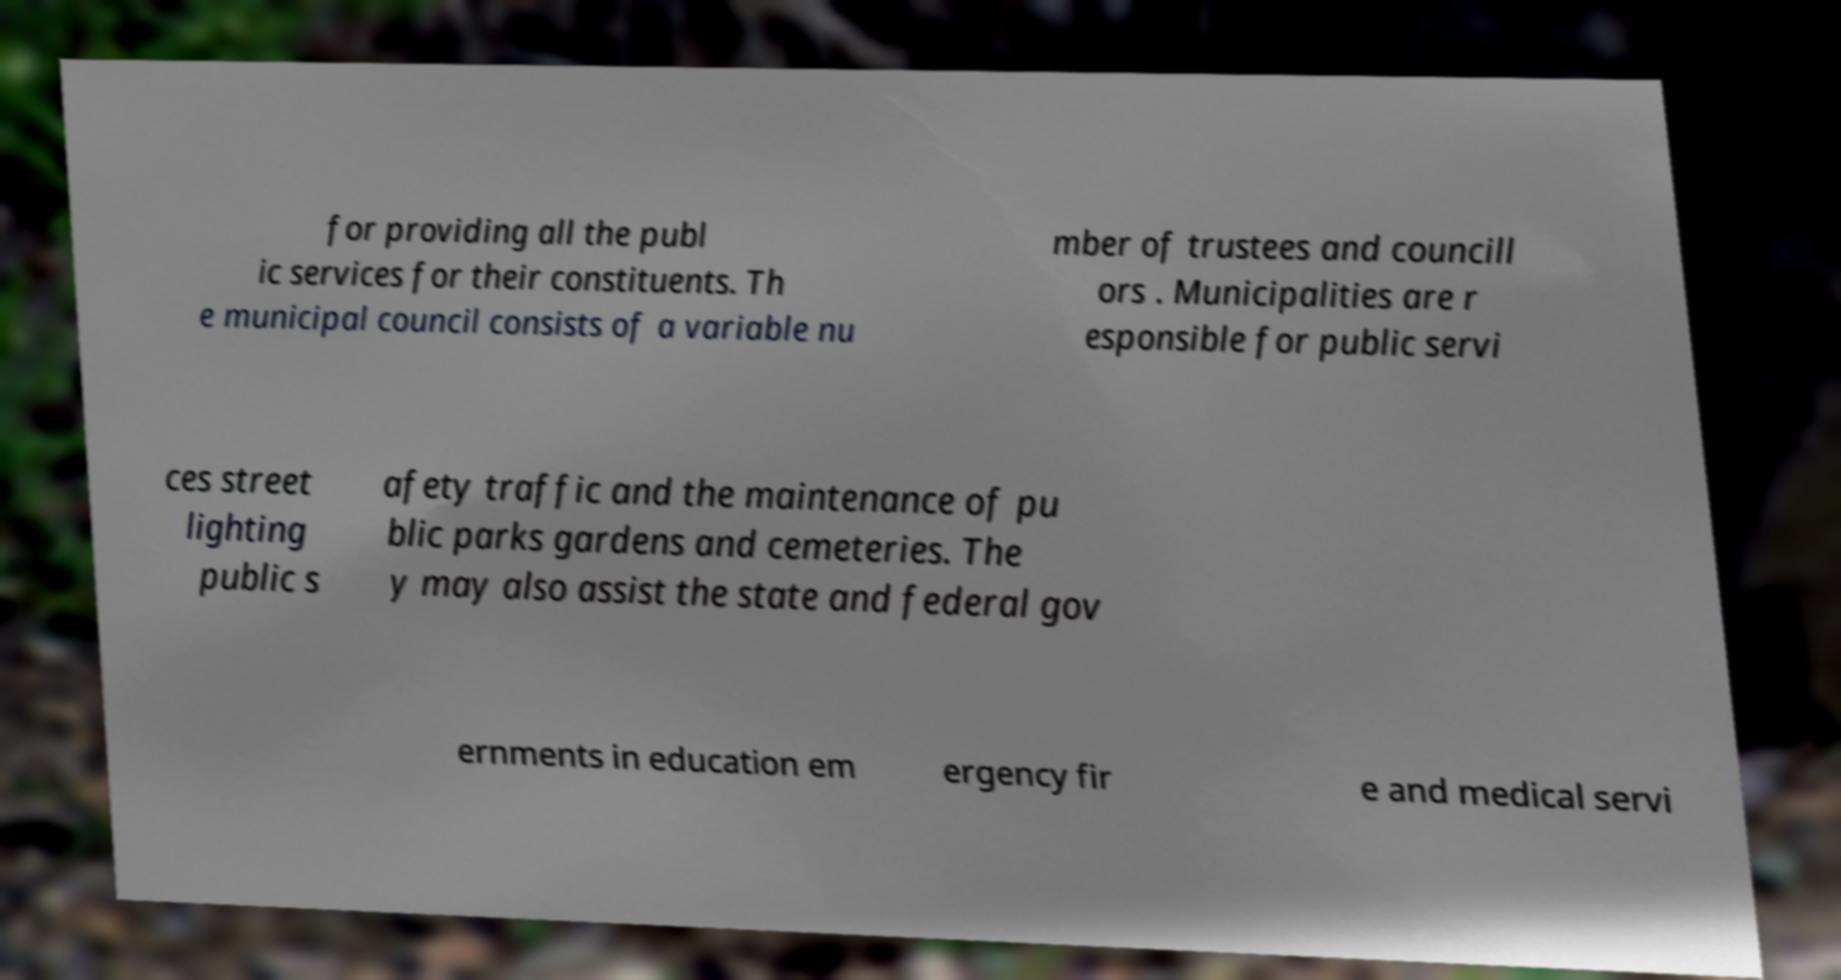Can you read and provide the text displayed in the image?This photo seems to have some interesting text. Can you extract and type it out for me? for providing all the publ ic services for their constituents. Th e municipal council consists of a variable nu mber of trustees and councill ors . Municipalities are r esponsible for public servi ces street lighting public s afety traffic and the maintenance of pu blic parks gardens and cemeteries. The y may also assist the state and federal gov ernments in education em ergency fir e and medical servi 